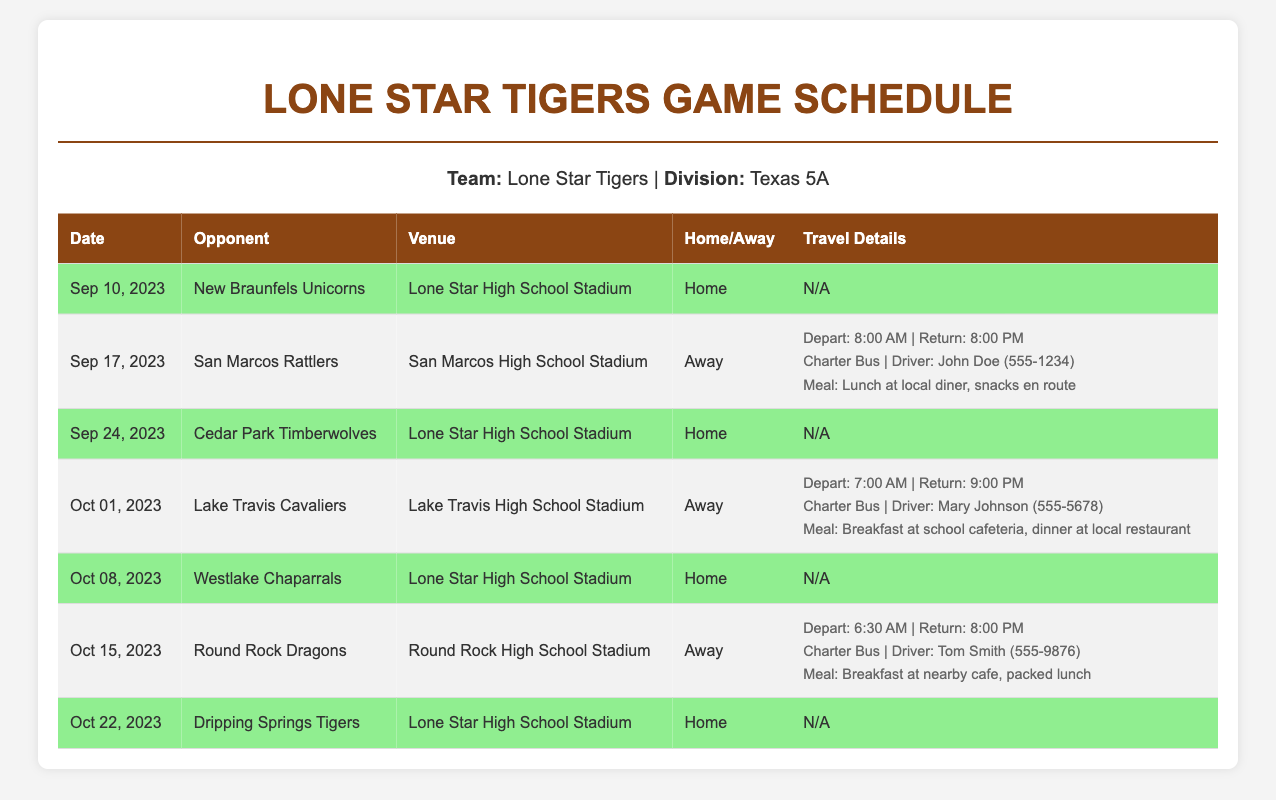What is the name of the team? The document lists the team name as "Lone Star Tigers."
Answer: Lone Star Tigers How many home games are scheduled? The document shows a total of four games classified as home in the schedule.
Answer: 4 Who is the opponent for the game on October 1, 2023? The document specifies "Lake Travis Cavaliers" as the opponent for this date.
Answer: Lake Travis Cavaliers What is the venue for the game against the New Braunfels Unicorns? The game is scheduled to be held at "Lone Star High School Stadium."
Answer: Lone Star High School Stadium What time does the team depart for the game against the San Marcos Rattlers? The document states that the departure time for this game is "8:00 AM."
Answer: 8:00 AM How will the team travel to the away game on October 15, 2023? The travel arrangements for this game include "Charter Bus."
Answer: Charter Bus What meal is provided for the away game against Lake Travis? The document lists "Breakfast at school cafeteria, dinner at local restaurant" as the meal arrangements.
Answer: Breakfast at school cafeteria, dinner at local restaurant On which date is the game against the Dripping Springs Tigers? According to the document, this game is scheduled for "October 22, 2023."
Answer: October 22, 2023 